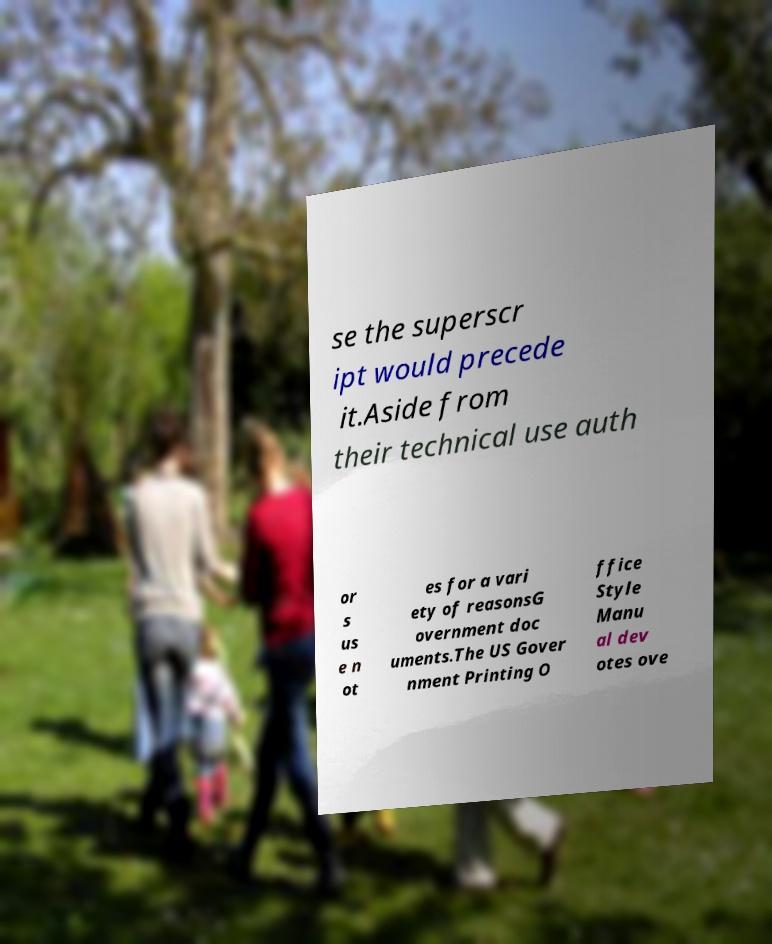Could you assist in decoding the text presented in this image and type it out clearly? se the superscr ipt would precede it.Aside from their technical use auth or s us e n ot es for a vari ety of reasonsG overnment doc uments.The US Gover nment Printing O ffice Style Manu al dev otes ove 